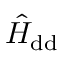Convert formula to latex. <formula><loc_0><loc_0><loc_500><loc_500>\hat { H } _ { d d }</formula> 